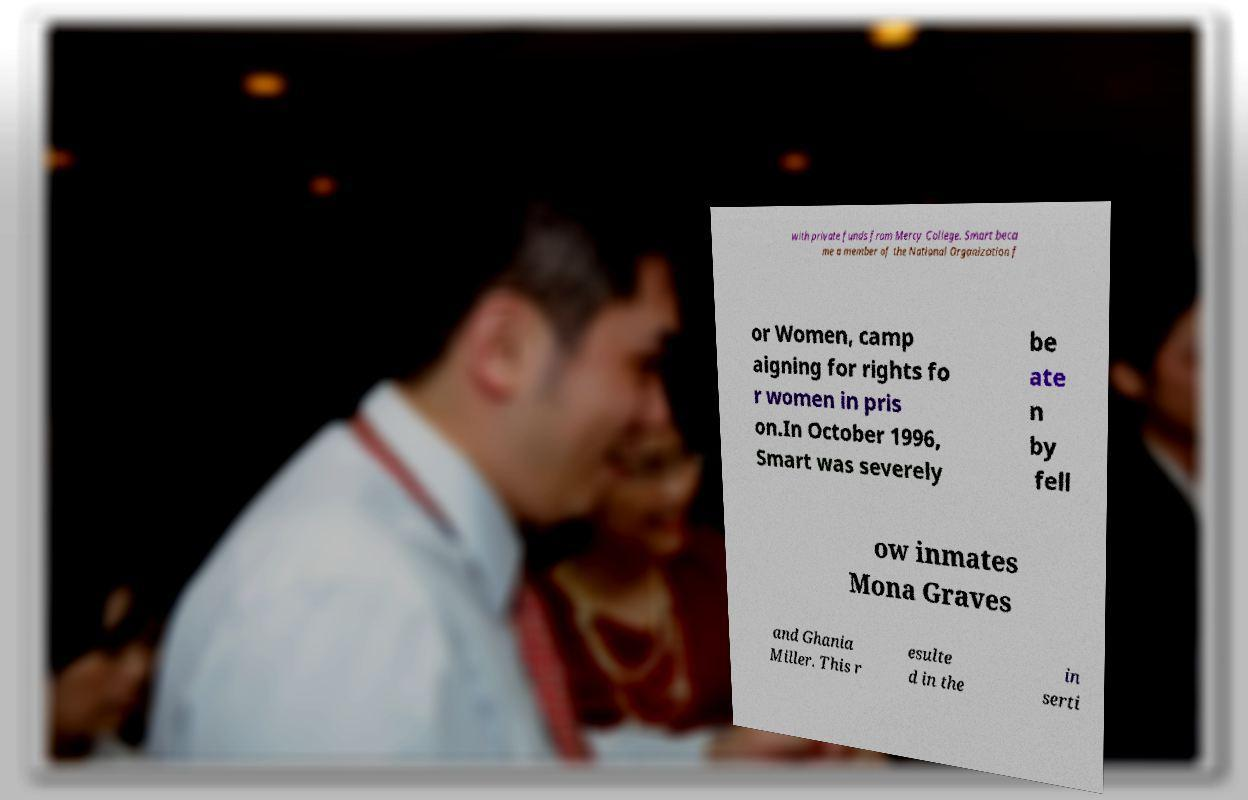Could you extract and type out the text from this image? with private funds from Mercy College. Smart beca me a member of the National Organization f or Women, camp aigning for rights fo r women in pris on.In October 1996, Smart was severely be ate n by fell ow inmates Mona Graves and Ghania Miller. This r esulte d in the in serti 